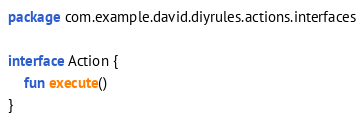<code> <loc_0><loc_0><loc_500><loc_500><_Kotlin_>package com.example.david.diyrules.actions.interfaces

interface Action {
    fun execute()
}</code> 